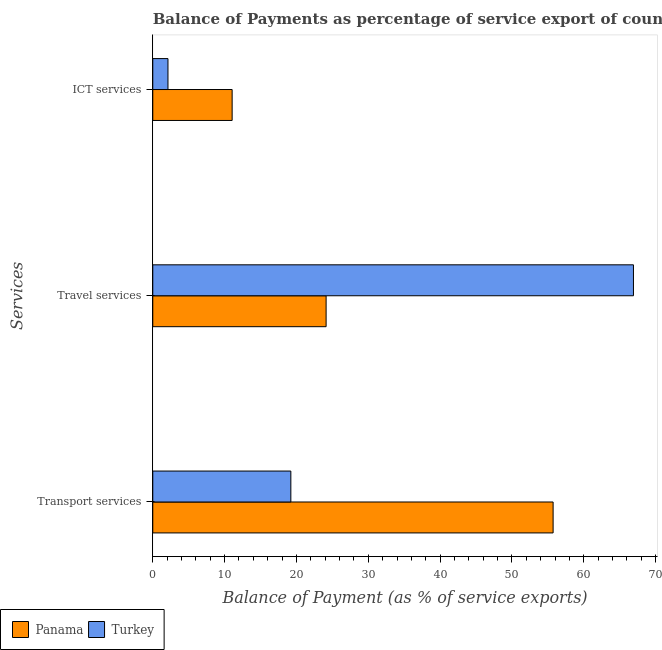How many bars are there on the 3rd tick from the top?
Offer a very short reply. 2. How many bars are there on the 1st tick from the bottom?
Offer a very short reply. 2. What is the label of the 1st group of bars from the top?
Provide a short and direct response. ICT services. What is the balance of payment of travel services in Panama?
Your answer should be compact. 24.13. Across all countries, what is the maximum balance of payment of transport services?
Provide a succinct answer. 55.73. Across all countries, what is the minimum balance of payment of ict services?
Make the answer very short. 2.12. In which country was the balance of payment of ict services maximum?
Offer a very short reply. Panama. What is the total balance of payment of transport services in the graph?
Provide a short and direct response. 74.95. What is the difference between the balance of payment of transport services in Turkey and that in Panama?
Keep it short and to the point. -36.51. What is the difference between the balance of payment of travel services in Turkey and the balance of payment of transport services in Panama?
Your answer should be compact. 11.18. What is the average balance of payment of travel services per country?
Provide a short and direct response. 45.52. What is the difference between the balance of payment of ict services and balance of payment of transport services in Panama?
Your answer should be very brief. -44.68. In how many countries, is the balance of payment of travel services greater than 20 %?
Offer a very short reply. 2. What is the ratio of the balance of payment of transport services in Panama to that in Turkey?
Offer a terse response. 2.9. Is the difference between the balance of payment of travel services in Turkey and Panama greater than the difference between the balance of payment of transport services in Turkey and Panama?
Offer a very short reply. Yes. What is the difference between the highest and the second highest balance of payment of travel services?
Keep it short and to the point. 42.79. What is the difference between the highest and the lowest balance of payment of transport services?
Your response must be concise. 36.51. In how many countries, is the balance of payment of travel services greater than the average balance of payment of travel services taken over all countries?
Your answer should be very brief. 1. How many bars are there?
Ensure brevity in your answer.  6. How many countries are there in the graph?
Offer a very short reply. 2. What is the difference between two consecutive major ticks on the X-axis?
Offer a very short reply. 10. Does the graph contain grids?
Provide a short and direct response. No. How many legend labels are there?
Your answer should be very brief. 2. How are the legend labels stacked?
Your response must be concise. Horizontal. What is the title of the graph?
Your answer should be very brief. Balance of Payments as percentage of service export of countries in 2006. What is the label or title of the X-axis?
Keep it short and to the point. Balance of Payment (as % of service exports). What is the label or title of the Y-axis?
Provide a short and direct response. Services. What is the Balance of Payment (as % of service exports) of Panama in Transport services?
Ensure brevity in your answer.  55.73. What is the Balance of Payment (as % of service exports) in Turkey in Transport services?
Keep it short and to the point. 19.22. What is the Balance of Payment (as % of service exports) in Panama in Travel services?
Ensure brevity in your answer.  24.13. What is the Balance of Payment (as % of service exports) of Turkey in Travel services?
Your response must be concise. 66.92. What is the Balance of Payment (as % of service exports) in Panama in ICT services?
Offer a very short reply. 11.05. What is the Balance of Payment (as % of service exports) of Turkey in ICT services?
Your answer should be compact. 2.12. Across all Services, what is the maximum Balance of Payment (as % of service exports) of Panama?
Provide a short and direct response. 55.73. Across all Services, what is the maximum Balance of Payment (as % of service exports) in Turkey?
Ensure brevity in your answer.  66.92. Across all Services, what is the minimum Balance of Payment (as % of service exports) in Panama?
Ensure brevity in your answer.  11.05. Across all Services, what is the minimum Balance of Payment (as % of service exports) of Turkey?
Offer a terse response. 2.12. What is the total Balance of Payment (as % of service exports) of Panama in the graph?
Your response must be concise. 90.91. What is the total Balance of Payment (as % of service exports) of Turkey in the graph?
Ensure brevity in your answer.  88.25. What is the difference between the Balance of Payment (as % of service exports) in Panama in Transport services and that in Travel services?
Your answer should be compact. 31.6. What is the difference between the Balance of Payment (as % of service exports) in Turkey in Transport services and that in Travel services?
Make the answer very short. -47.7. What is the difference between the Balance of Payment (as % of service exports) in Panama in Transport services and that in ICT services?
Make the answer very short. 44.68. What is the difference between the Balance of Payment (as % of service exports) in Turkey in Transport services and that in ICT services?
Your answer should be very brief. 17.1. What is the difference between the Balance of Payment (as % of service exports) of Panama in Travel services and that in ICT services?
Offer a very short reply. 13.08. What is the difference between the Balance of Payment (as % of service exports) in Turkey in Travel services and that in ICT services?
Provide a short and direct response. 64.8. What is the difference between the Balance of Payment (as % of service exports) of Panama in Transport services and the Balance of Payment (as % of service exports) of Turkey in Travel services?
Offer a terse response. -11.18. What is the difference between the Balance of Payment (as % of service exports) of Panama in Transport services and the Balance of Payment (as % of service exports) of Turkey in ICT services?
Provide a succinct answer. 53.62. What is the difference between the Balance of Payment (as % of service exports) in Panama in Travel services and the Balance of Payment (as % of service exports) in Turkey in ICT services?
Provide a short and direct response. 22.01. What is the average Balance of Payment (as % of service exports) of Panama per Services?
Ensure brevity in your answer.  30.3. What is the average Balance of Payment (as % of service exports) of Turkey per Services?
Your answer should be very brief. 29.42. What is the difference between the Balance of Payment (as % of service exports) in Panama and Balance of Payment (as % of service exports) in Turkey in Transport services?
Your answer should be very brief. 36.51. What is the difference between the Balance of Payment (as % of service exports) in Panama and Balance of Payment (as % of service exports) in Turkey in Travel services?
Offer a very short reply. -42.79. What is the difference between the Balance of Payment (as % of service exports) of Panama and Balance of Payment (as % of service exports) of Turkey in ICT services?
Your response must be concise. 8.93. What is the ratio of the Balance of Payment (as % of service exports) of Panama in Transport services to that in Travel services?
Your answer should be compact. 2.31. What is the ratio of the Balance of Payment (as % of service exports) of Turkey in Transport services to that in Travel services?
Keep it short and to the point. 0.29. What is the ratio of the Balance of Payment (as % of service exports) in Panama in Transport services to that in ICT services?
Provide a short and direct response. 5.04. What is the ratio of the Balance of Payment (as % of service exports) in Turkey in Transport services to that in ICT services?
Ensure brevity in your answer.  9.08. What is the ratio of the Balance of Payment (as % of service exports) of Panama in Travel services to that in ICT services?
Keep it short and to the point. 2.18. What is the ratio of the Balance of Payment (as % of service exports) in Turkey in Travel services to that in ICT services?
Offer a terse response. 31.62. What is the difference between the highest and the second highest Balance of Payment (as % of service exports) of Panama?
Keep it short and to the point. 31.6. What is the difference between the highest and the second highest Balance of Payment (as % of service exports) of Turkey?
Offer a terse response. 47.7. What is the difference between the highest and the lowest Balance of Payment (as % of service exports) in Panama?
Provide a succinct answer. 44.68. What is the difference between the highest and the lowest Balance of Payment (as % of service exports) in Turkey?
Ensure brevity in your answer.  64.8. 